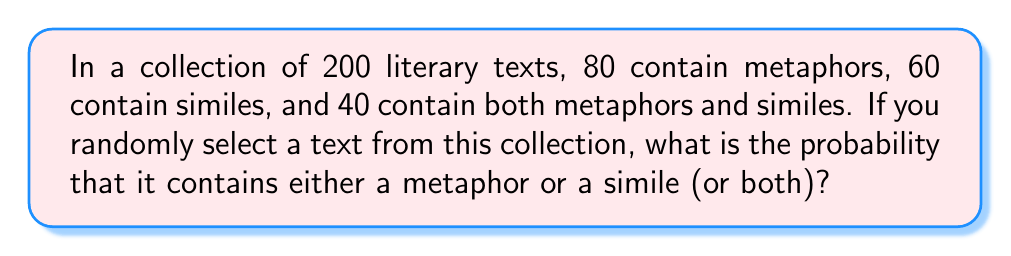What is the answer to this math problem? Let's approach this step-by-step using set theory and probability:

1) Let M be the set of texts with metaphors, and S be the set of texts with similes.

2) We're given:
   $|M| = 80$ (number of texts with metaphors)
   $|S| = 60$ (number of texts with similes)
   $|M \cap S| = 40$ (number of texts with both metaphors and similes)
   Total texts = 200

3) We need to find $P(M \cup S)$, the probability of a text containing either a metaphor or a simile (or both).

4) Using the addition rule of probability:
   $P(M \cup S) = P(M) + P(S) - P(M \cap S)$

5) Calculate each probability:
   $P(M) = \frac{80}{200} = 0.4$
   $P(S) = \frac{60}{200} = 0.3$
   $P(M \cap S) = \frac{40}{200} = 0.2$

6) Substitute these values into the formula:
   $P(M \cup S) = 0.4 + 0.3 - 0.2 = 0.5$

7) Therefore, the probability of randomly selecting a text with either a metaphor or a simile (or both) is 0.5 or 50%.
Answer: 0.5 